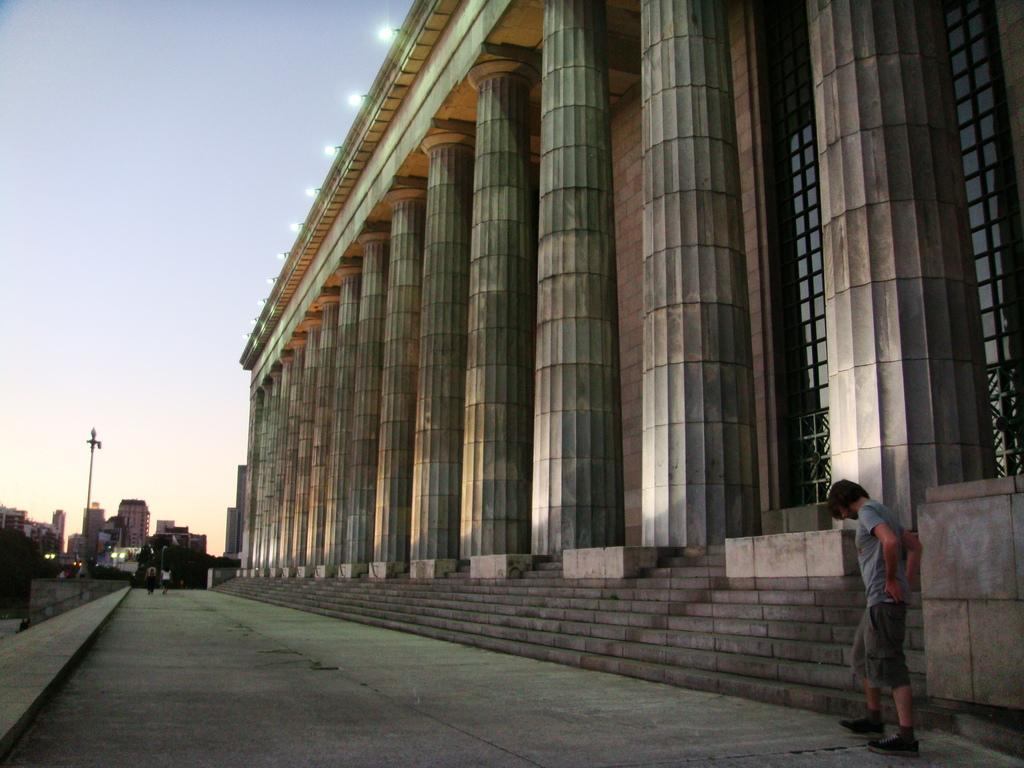What type of structures can be seen in the image? There are buildings in the image. What architectural features are present in the image? There are pillars and steps in the image. How many persons are visible on the road in the image? There are three persons on the road in the image. What type of vegetation is present in the image? There are trees in the image. What is the purpose of the light pole in the image? The light pole is likely used for illumination. What is visible in the background of the image? The sky is visible in the image. Can you determine the time of day the image was taken? The image is likely taken during the day, as the sky appears bright. What type of hospital can be seen in the image? There is no hospital present in the image. What did the dad eat for breakfast in the image? There is no dad or breakfast mentioned in the image. 